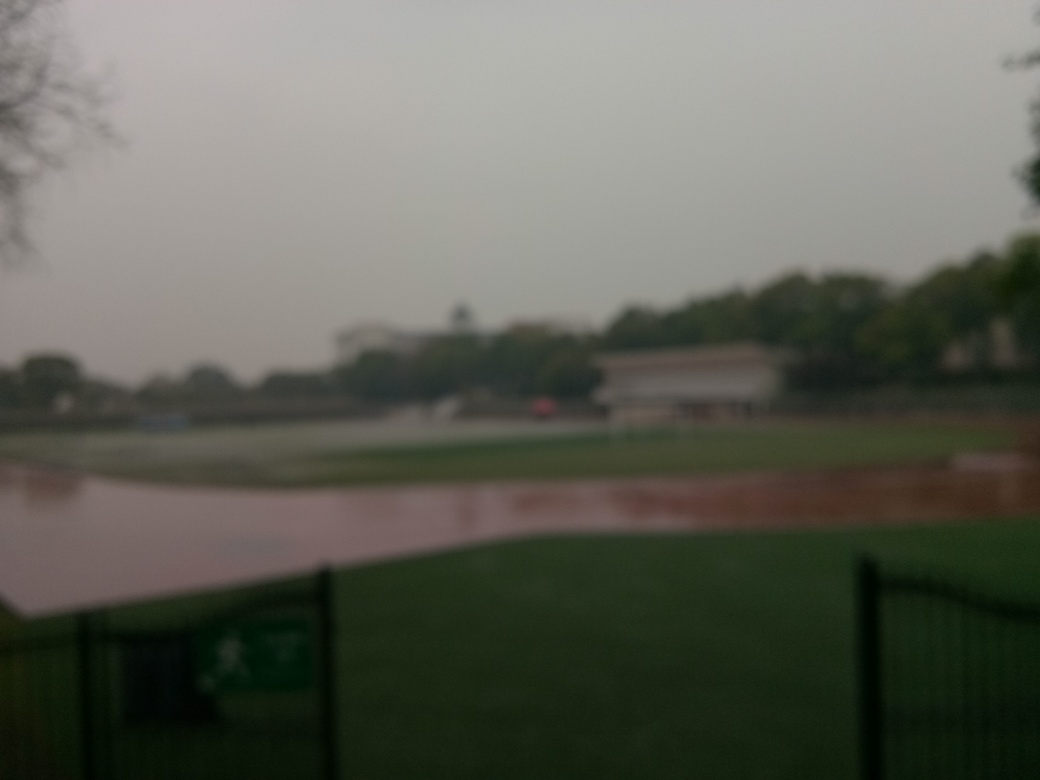What could be improved in the composition of this shot? To improve the composition of this shot, ensuring proper focus is essential to add clarity. Additionally, if it were possible, waiting for a moment with better lighting or a more compelling sky could add interest. Including a focal point such as a person, an animal, or an interesting object could also infuse the scene with life and offer viewers a place to rest their eyes. 